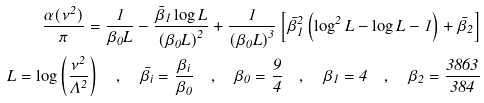<formula> <loc_0><loc_0><loc_500><loc_500>\frac { \alpha ( \nu ^ { 2 } ) } { \pi } = \frac { 1 } { \beta _ { 0 } L } - \frac { \bar { \beta } _ { 1 } \log L } { \left ( \beta _ { 0 } L \right ) ^ { 2 } } + \frac { 1 } { \left ( \beta _ { 0 } L \right ) ^ { 3 } } \left [ \bar { \beta } _ { 1 } ^ { 2 } \left ( \log ^ { 2 } L - \log L - 1 \right ) + \bar { \beta } _ { 2 } \right ] \\ L = \log \left ( \frac { \nu ^ { 2 } } { \Lambda ^ { 2 } } \right ) \quad , \quad \bar { \beta } _ { i } = \frac { \beta _ { i } } { \beta _ { 0 } } \quad , \quad \beta _ { 0 } = \frac { 9 } { 4 } \quad , \quad \beta _ { 1 } = 4 \quad , \quad \beta _ { 2 } = \frac { 3 8 6 3 } { 3 8 4 }</formula> 